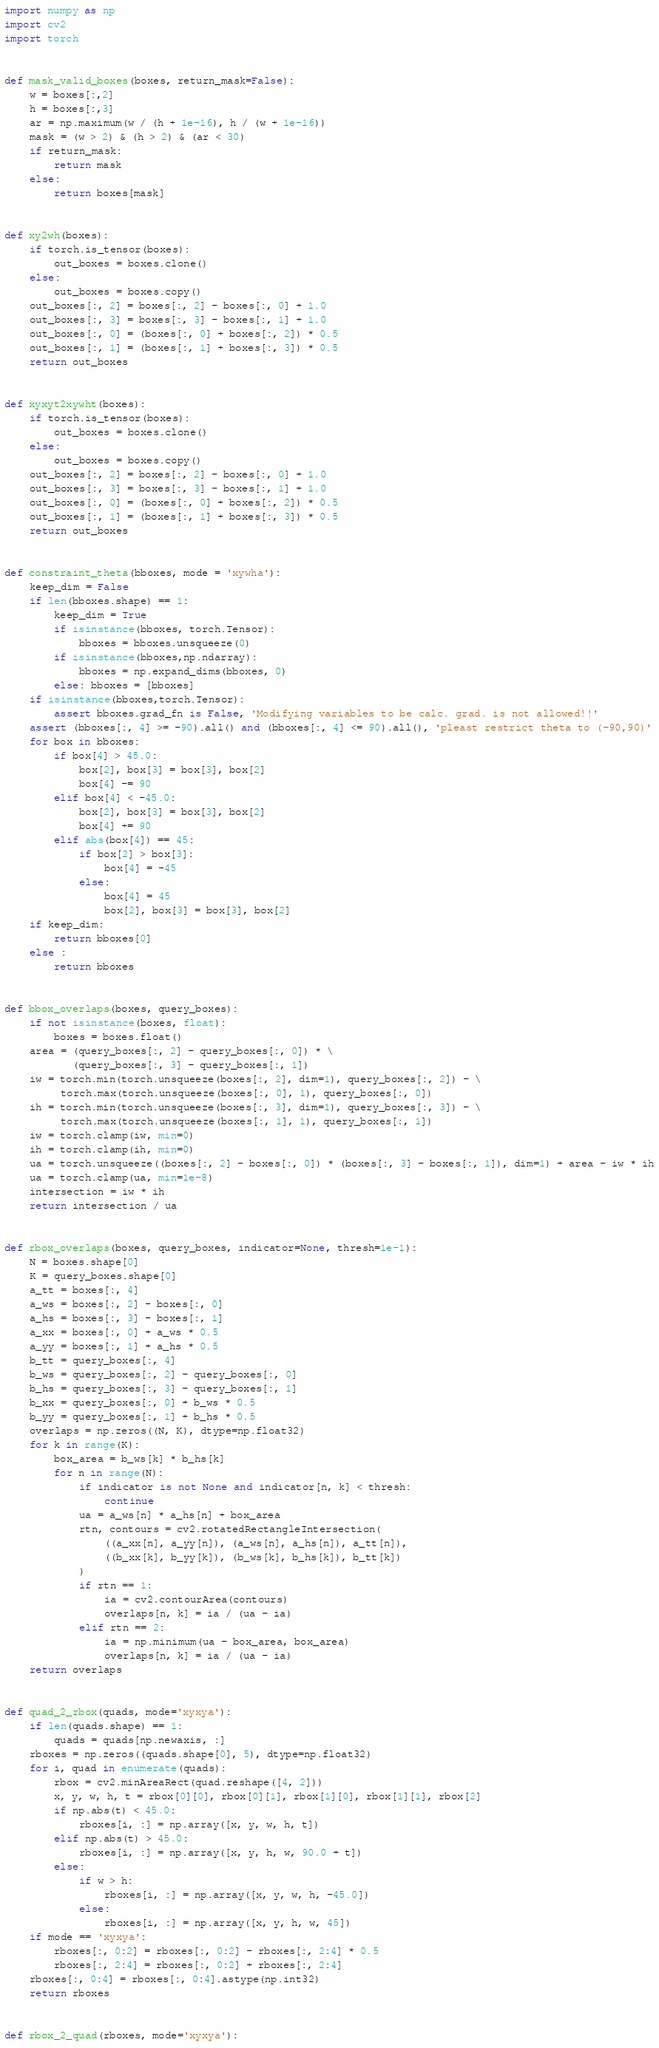Convert code to text. <code><loc_0><loc_0><loc_500><loc_500><_Python_>import numpy as np
import cv2
import torch


def mask_valid_boxes(boxes, return_mask=False):
    w = boxes[:,2]
    h = boxes[:,3]
    ar = np.maximum(w / (h + 1e-16), h / (w + 1e-16))
    mask = (w > 2) & (h > 2) & (ar < 30)
    if return_mask:
        return mask
    else:
        return boxes[mask]


def xy2wh(boxes):
    if torch.is_tensor(boxes):
        out_boxes = boxes.clone()
    else:
        out_boxes = boxes.copy()
    out_boxes[:, 2] = boxes[:, 2] - boxes[:, 0] + 1.0
    out_boxes[:, 3] = boxes[:, 3] - boxes[:, 1] + 1.0
    out_boxes[:, 0] = (boxes[:, 0] + boxes[:, 2]) * 0.5
    out_boxes[:, 1] = (boxes[:, 1] + boxes[:, 3]) * 0.5
    return out_boxes


def xyxyt2xywht(boxes):
    if torch.is_tensor(boxes):
        out_boxes = boxes.clone()
    else:
        out_boxes = boxes.copy()
    out_boxes[:, 2] = boxes[:, 2] - boxes[:, 0] + 1.0
    out_boxes[:, 3] = boxes[:, 3] - boxes[:, 1] + 1.0
    out_boxes[:, 0] = (boxes[:, 0] + boxes[:, 2]) * 0.5
    out_boxes[:, 1] = (boxes[:, 1] + boxes[:, 3]) * 0.5
    return out_boxes


def constraint_theta(bboxes, mode = 'xywha'):
    keep_dim = False
    if len(bboxes.shape) == 1:
        keep_dim = True
        if isinstance(bboxes, torch.Tensor):
            bboxes = bboxes.unsqueeze(0)
        if isinstance(bboxes,np.ndarray):
            bboxes = np.expand_dims(bboxes, 0)
        else: bboxes = [bboxes]
    if isinstance(bboxes,torch.Tensor):
        assert bboxes.grad_fn is False, 'Modifying variables to be calc. grad. is not allowed!!'
    assert (bboxes[:, 4] >= -90).all() and (bboxes[:, 4] <= 90).all(), 'pleast restrict theta to (-90,90)'
    for box in bboxes:
        if box[4] > 45.0:
            box[2], box[3] = box[3], box[2]
            box[4] -= 90
        elif box[4] < -45.0:
            box[2], box[3] = box[3], box[2]
            box[4] += 90
        elif abs(box[4]) == 45:
            if box[2] > box[3]:
                box[4] = -45
            else:
                box[4] = 45
                box[2], box[3] = box[3], box[2]
    if keep_dim:
        return bboxes[0]
    else :
        return bboxes


def bbox_overlaps(boxes, query_boxes):
    if not isinstance(boxes, float):
        boxes = boxes.float()
    area = (query_boxes[:, 2] - query_boxes[:, 0]) * \
           (query_boxes[:, 3] - query_boxes[:, 1])
    iw = torch.min(torch.unsqueeze(boxes[:, 2], dim=1), query_boxes[:, 2]) - \
         torch.max(torch.unsqueeze(boxes[:, 0], 1), query_boxes[:, 0])
    ih = torch.min(torch.unsqueeze(boxes[:, 3], dim=1), query_boxes[:, 3]) - \
         torch.max(torch.unsqueeze(boxes[:, 1], 1), query_boxes[:, 1])
    iw = torch.clamp(iw, min=0)
    ih = torch.clamp(ih, min=0)
    ua = torch.unsqueeze((boxes[:, 2] - boxes[:, 0]) * (boxes[:, 3] - boxes[:, 1]), dim=1) + area - iw * ih
    ua = torch.clamp(ua, min=1e-8)
    intersection = iw * ih
    return intersection / ua


def rbox_overlaps(boxes, query_boxes, indicator=None, thresh=1e-1):
    N = boxes.shape[0]
    K = query_boxes.shape[0]
    a_tt = boxes[:, 4]
    a_ws = boxes[:, 2] - boxes[:, 0]
    a_hs = boxes[:, 3] - boxes[:, 1]
    a_xx = boxes[:, 0] + a_ws * 0.5
    a_yy = boxes[:, 1] + a_hs * 0.5
    b_tt = query_boxes[:, 4]
    b_ws = query_boxes[:, 2] - query_boxes[:, 0]
    b_hs = query_boxes[:, 3] - query_boxes[:, 1]
    b_xx = query_boxes[:, 0] + b_ws * 0.5
    b_yy = query_boxes[:, 1] + b_hs * 0.5
    overlaps = np.zeros((N, K), dtype=np.float32)
    for k in range(K):
        box_area = b_ws[k] * b_hs[k]
        for n in range(N):
            if indicator is not None and indicator[n, k] < thresh:
                continue
            ua = a_ws[n] * a_hs[n] + box_area
            rtn, contours = cv2.rotatedRectangleIntersection(
                ((a_xx[n], a_yy[n]), (a_ws[n], a_hs[n]), a_tt[n]),
                ((b_xx[k], b_yy[k]), (b_ws[k], b_hs[k]), b_tt[k])
            )
            if rtn == 1:
                ia = cv2.contourArea(contours)
                overlaps[n, k] = ia / (ua - ia)
            elif rtn == 2:
                ia = np.minimum(ua - box_area, box_area)
                overlaps[n, k] = ia / (ua - ia)
    return overlaps


def quad_2_rbox(quads, mode='xyxya'):
    if len(quads.shape) == 1:
        quads = quads[np.newaxis, :]
    rboxes = np.zeros((quads.shape[0], 5), dtype=np.float32)
    for i, quad in enumerate(quads):
        rbox = cv2.minAreaRect(quad.reshape([4, 2]))
        x, y, w, h, t = rbox[0][0], rbox[0][1], rbox[1][0], rbox[1][1], rbox[2]
        if np.abs(t) < 45.0:
            rboxes[i, :] = np.array([x, y, w, h, t])
        elif np.abs(t) > 45.0:
            rboxes[i, :] = np.array([x, y, h, w, 90.0 + t])
        else:
            if w > h:
                rboxes[i, :] = np.array([x, y, w, h, -45.0])
            else:
                rboxes[i, :] = np.array([x, y, h, w, 45])
    if mode == 'xyxya':
        rboxes[:, 0:2] = rboxes[:, 0:2] - rboxes[:, 2:4] * 0.5
        rboxes[:, 2:4] = rboxes[:, 0:2] + rboxes[:, 2:4]
    rboxes[:, 0:4] = rboxes[:, 0:4].astype(np.int32)
    return rboxes


def rbox_2_quad(rboxes, mode='xyxya'):</code> 